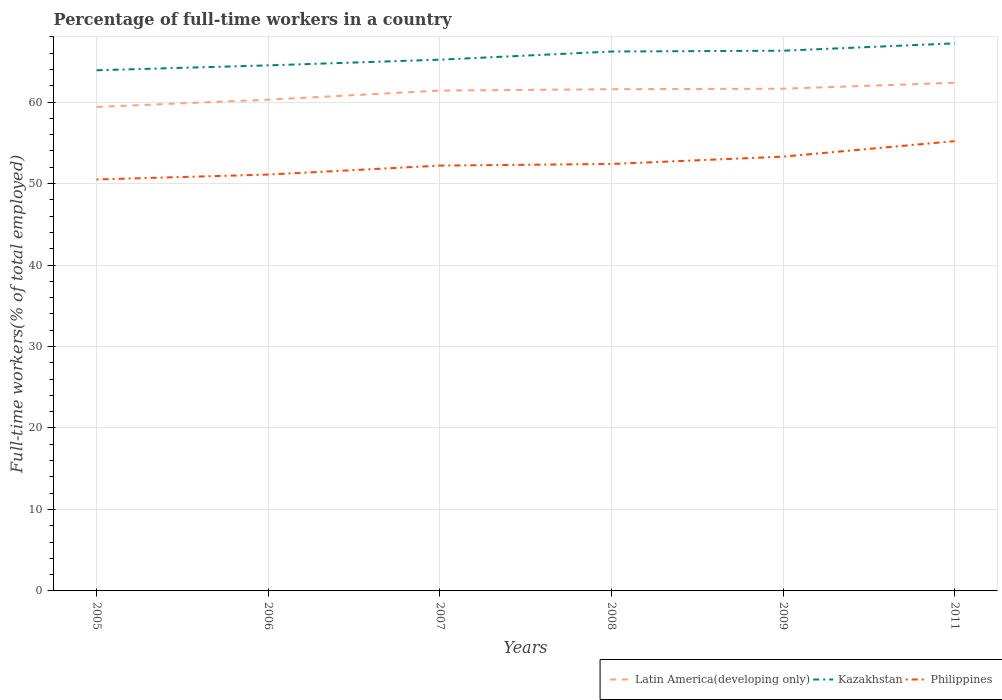Does the line corresponding to Latin America(developing only) intersect with the line corresponding to Philippines?
Ensure brevity in your answer.  No. Across all years, what is the maximum percentage of full-time workers in Philippines?
Give a very brief answer. 50.5. In which year was the percentage of full-time workers in Philippines maximum?
Provide a short and direct response. 2005. What is the difference between the highest and the second highest percentage of full-time workers in Latin America(developing only)?
Provide a succinct answer. 2.97. What is the difference between the highest and the lowest percentage of full-time workers in Philippines?
Make the answer very short. 2. How many lines are there?
Make the answer very short. 3. What is the difference between two consecutive major ticks on the Y-axis?
Ensure brevity in your answer.  10. Does the graph contain grids?
Your answer should be very brief. Yes. Where does the legend appear in the graph?
Offer a terse response. Bottom right. How are the legend labels stacked?
Provide a short and direct response. Horizontal. What is the title of the graph?
Provide a succinct answer. Percentage of full-time workers in a country. Does "Aruba" appear as one of the legend labels in the graph?
Offer a very short reply. No. What is the label or title of the Y-axis?
Your response must be concise. Full-time workers(% of total employed). What is the Full-time workers(% of total employed) in Latin America(developing only) in 2005?
Your answer should be very brief. 59.4. What is the Full-time workers(% of total employed) of Kazakhstan in 2005?
Ensure brevity in your answer.  63.9. What is the Full-time workers(% of total employed) of Philippines in 2005?
Give a very brief answer. 50.5. What is the Full-time workers(% of total employed) in Latin America(developing only) in 2006?
Offer a very short reply. 60.29. What is the Full-time workers(% of total employed) in Kazakhstan in 2006?
Make the answer very short. 64.5. What is the Full-time workers(% of total employed) in Philippines in 2006?
Offer a terse response. 51.1. What is the Full-time workers(% of total employed) in Latin America(developing only) in 2007?
Provide a short and direct response. 61.41. What is the Full-time workers(% of total employed) of Kazakhstan in 2007?
Make the answer very short. 65.2. What is the Full-time workers(% of total employed) of Philippines in 2007?
Your response must be concise. 52.2. What is the Full-time workers(% of total employed) of Latin America(developing only) in 2008?
Your answer should be very brief. 61.57. What is the Full-time workers(% of total employed) of Kazakhstan in 2008?
Your answer should be very brief. 66.2. What is the Full-time workers(% of total employed) in Philippines in 2008?
Offer a terse response. 52.4. What is the Full-time workers(% of total employed) of Latin America(developing only) in 2009?
Keep it short and to the point. 61.64. What is the Full-time workers(% of total employed) of Kazakhstan in 2009?
Offer a terse response. 66.3. What is the Full-time workers(% of total employed) of Philippines in 2009?
Make the answer very short. 53.3. What is the Full-time workers(% of total employed) of Latin America(developing only) in 2011?
Give a very brief answer. 62.37. What is the Full-time workers(% of total employed) in Kazakhstan in 2011?
Provide a short and direct response. 67.2. What is the Full-time workers(% of total employed) in Philippines in 2011?
Give a very brief answer. 55.2. Across all years, what is the maximum Full-time workers(% of total employed) of Latin America(developing only)?
Make the answer very short. 62.37. Across all years, what is the maximum Full-time workers(% of total employed) in Kazakhstan?
Your response must be concise. 67.2. Across all years, what is the maximum Full-time workers(% of total employed) of Philippines?
Your answer should be compact. 55.2. Across all years, what is the minimum Full-time workers(% of total employed) in Latin America(developing only)?
Make the answer very short. 59.4. Across all years, what is the minimum Full-time workers(% of total employed) of Kazakhstan?
Give a very brief answer. 63.9. Across all years, what is the minimum Full-time workers(% of total employed) in Philippines?
Offer a terse response. 50.5. What is the total Full-time workers(% of total employed) in Latin America(developing only) in the graph?
Ensure brevity in your answer.  366.67. What is the total Full-time workers(% of total employed) in Kazakhstan in the graph?
Provide a short and direct response. 393.3. What is the total Full-time workers(% of total employed) in Philippines in the graph?
Provide a succinct answer. 314.7. What is the difference between the Full-time workers(% of total employed) of Latin America(developing only) in 2005 and that in 2006?
Make the answer very short. -0.89. What is the difference between the Full-time workers(% of total employed) in Philippines in 2005 and that in 2006?
Provide a short and direct response. -0.6. What is the difference between the Full-time workers(% of total employed) of Latin America(developing only) in 2005 and that in 2007?
Your response must be concise. -2.01. What is the difference between the Full-time workers(% of total employed) of Latin America(developing only) in 2005 and that in 2008?
Your answer should be very brief. -2.18. What is the difference between the Full-time workers(% of total employed) of Kazakhstan in 2005 and that in 2008?
Your response must be concise. -2.3. What is the difference between the Full-time workers(% of total employed) of Latin America(developing only) in 2005 and that in 2009?
Offer a very short reply. -2.24. What is the difference between the Full-time workers(% of total employed) of Philippines in 2005 and that in 2009?
Keep it short and to the point. -2.8. What is the difference between the Full-time workers(% of total employed) in Latin America(developing only) in 2005 and that in 2011?
Offer a terse response. -2.97. What is the difference between the Full-time workers(% of total employed) in Kazakhstan in 2005 and that in 2011?
Your answer should be very brief. -3.3. What is the difference between the Full-time workers(% of total employed) in Latin America(developing only) in 2006 and that in 2007?
Keep it short and to the point. -1.12. What is the difference between the Full-time workers(% of total employed) of Philippines in 2006 and that in 2007?
Keep it short and to the point. -1.1. What is the difference between the Full-time workers(% of total employed) in Latin America(developing only) in 2006 and that in 2008?
Your answer should be very brief. -1.28. What is the difference between the Full-time workers(% of total employed) in Philippines in 2006 and that in 2008?
Provide a succinct answer. -1.3. What is the difference between the Full-time workers(% of total employed) in Latin America(developing only) in 2006 and that in 2009?
Ensure brevity in your answer.  -1.35. What is the difference between the Full-time workers(% of total employed) in Kazakhstan in 2006 and that in 2009?
Your answer should be very brief. -1.8. What is the difference between the Full-time workers(% of total employed) in Philippines in 2006 and that in 2009?
Your answer should be very brief. -2.2. What is the difference between the Full-time workers(% of total employed) of Latin America(developing only) in 2006 and that in 2011?
Provide a succinct answer. -2.08. What is the difference between the Full-time workers(% of total employed) of Philippines in 2006 and that in 2011?
Provide a succinct answer. -4.1. What is the difference between the Full-time workers(% of total employed) in Latin America(developing only) in 2007 and that in 2008?
Keep it short and to the point. -0.17. What is the difference between the Full-time workers(% of total employed) of Kazakhstan in 2007 and that in 2008?
Offer a very short reply. -1. What is the difference between the Full-time workers(% of total employed) in Philippines in 2007 and that in 2008?
Make the answer very short. -0.2. What is the difference between the Full-time workers(% of total employed) of Latin America(developing only) in 2007 and that in 2009?
Make the answer very short. -0.23. What is the difference between the Full-time workers(% of total employed) of Kazakhstan in 2007 and that in 2009?
Keep it short and to the point. -1.1. What is the difference between the Full-time workers(% of total employed) in Philippines in 2007 and that in 2009?
Provide a succinct answer. -1.1. What is the difference between the Full-time workers(% of total employed) of Latin America(developing only) in 2007 and that in 2011?
Your response must be concise. -0.96. What is the difference between the Full-time workers(% of total employed) of Kazakhstan in 2007 and that in 2011?
Ensure brevity in your answer.  -2. What is the difference between the Full-time workers(% of total employed) in Latin America(developing only) in 2008 and that in 2009?
Give a very brief answer. -0.06. What is the difference between the Full-time workers(% of total employed) in Kazakhstan in 2008 and that in 2009?
Give a very brief answer. -0.1. What is the difference between the Full-time workers(% of total employed) in Philippines in 2008 and that in 2009?
Make the answer very short. -0.9. What is the difference between the Full-time workers(% of total employed) in Latin America(developing only) in 2008 and that in 2011?
Ensure brevity in your answer.  -0.79. What is the difference between the Full-time workers(% of total employed) in Latin America(developing only) in 2009 and that in 2011?
Your response must be concise. -0.73. What is the difference between the Full-time workers(% of total employed) in Kazakhstan in 2009 and that in 2011?
Your answer should be compact. -0.9. What is the difference between the Full-time workers(% of total employed) of Philippines in 2009 and that in 2011?
Give a very brief answer. -1.9. What is the difference between the Full-time workers(% of total employed) of Latin America(developing only) in 2005 and the Full-time workers(% of total employed) of Kazakhstan in 2006?
Your response must be concise. -5.1. What is the difference between the Full-time workers(% of total employed) of Latin America(developing only) in 2005 and the Full-time workers(% of total employed) of Philippines in 2006?
Your response must be concise. 8.3. What is the difference between the Full-time workers(% of total employed) of Kazakhstan in 2005 and the Full-time workers(% of total employed) of Philippines in 2006?
Your response must be concise. 12.8. What is the difference between the Full-time workers(% of total employed) of Latin America(developing only) in 2005 and the Full-time workers(% of total employed) of Kazakhstan in 2007?
Provide a short and direct response. -5.8. What is the difference between the Full-time workers(% of total employed) in Latin America(developing only) in 2005 and the Full-time workers(% of total employed) in Philippines in 2007?
Keep it short and to the point. 7.2. What is the difference between the Full-time workers(% of total employed) in Kazakhstan in 2005 and the Full-time workers(% of total employed) in Philippines in 2007?
Ensure brevity in your answer.  11.7. What is the difference between the Full-time workers(% of total employed) of Latin America(developing only) in 2005 and the Full-time workers(% of total employed) of Kazakhstan in 2008?
Give a very brief answer. -6.8. What is the difference between the Full-time workers(% of total employed) of Latin America(developing only) in 2005 and the Full-time workers(% of total employed) of Philippines in 2008?
Your answer should be very brief. 7. What is the difference between the Full-time workers(% of total employed) in Latin America(developing only) in 2005 and the Full-time workers(% of total employed) in Kazakhstan in 2009?
Offer a very short reply. -6.9. What is the difference between the Full-time workers(% of total employed) in Latin America(developing only) in 2005 and the Full-time workers(% of total employed) in Philippines in 2009?
Give a very brief answer. 6.1. What is the difference between the Full-time workers(% of total employed) of Latin America(developing only) in 2005 and the Full-time workers(% of total employed) of Kazakhstan in 2011?
Your answer should be compact. -7.8. What is the difference between the Full-time workers(% of total employed) of Latin America(developing only) in 2005 and the Full-time workers(% of total employed) of Philippines in 2011?
Your answer should be compact. 4.2. What is the difference between the Full-time workers(% of total employed) in Kazakhstan in 2005 and the Full-time workers(% of total employed) in Philippines in 2011?
Keep it short and to the point. 8.7. What is the difference between the Full-time workers(% of total employed) in Latin America(developing only) in 2006 and the Full-time workers(% of total employed) in Kazakhstan in 2007?
Provide a short and direct response. -4.91. What is the difference between the Full-time workers(% of total employed) of Latin America(developing only) in 2006 and the Full-time workers(% of total employed) of Philippines in 2007?
Make the answer very short. 8.09. What is the difference between the Full-time workers(% of total employed) in Kazakhstan in 2006 and the Full-time workers(% of total employed) in Philippines in 2007?
Offer a very short reply. 12.3. What is the difference between the Full-time workers(% of total employed) in Latin America(developing only) in 2006 and the Full-time workers(% of total employed) in Kazakhstan in 2008?
Your response must be concise. -5.91. What is the difference between the Full-time workers(% of total employed) of Latin America(developing only) in 2006 and the Full-time workers(% of total employed) of Philippines in 2008?
Keep it short and to the point. 7.89. What is the difference between the Full-time workers(% of total employed) of Kazakhstan in 2006 and the Full-time workers(% of total employed) of Philippines in 2008?
Offer a terse response. 12.1. What is the difference between the Full-time workers(% of total employed) in Latin America(developing only) in 2006 and the Full-time workers(% of total employed) in Kazakhstan in 2009?
Your answer should be very brief. -6.01. What is the difference between the Full-time workers(% of total employed) in Latin America(developing only) in 2006 and the Full-time workers(% of total employed) in Philippines in 2009?
Provide a short and direct response. 6.99. What is the difference between the Full-time workers(% of total employed) of Kazakhstan in 2006 and the Full-time workers(% of total employed) of Philippines in 2009?
Offer a terse response. 11.2. What is the difference between the Full-time workers(% of total employed) in Latin America(developing only) in 2006 and the Full-time workers(% of total employed) in Kazakhstan in 2011?
Provide a succinct answer. -6.91. What is the difference between the Full-time workers(% of total employed) of Latin America(developing only) in 2006 and the Full-time workers(% of total employed) of Philippines in 2011?
Keep it short and to the point. 5.09. What is the difference between the Full-time workers(% of total employed) of Kazakhstan in 2006 and the Full-time workers(% of total employed) of Philippines in 2011?
Keep it short and to the point. 9.3. What is the difference between the Full-time workers(% of total employed) of Latin America(developing only) in 2007 and the Full-time workers(% of total employed) of Kazakhstan in 2008?
Offer a terse response. -4.79. What is the difference between the Full-time workers(% of total employed) of Latin America(developing only) in 2007 and the Full-time workers(% of total employed) of Philippines in 2008?
Your response must be concise. 9.01. What is the difference between the Full-time workers(% of total employed) in Kazakhstan in 2007 and the Full-time workers(% of total employed) in Philippines in 2008?
Keep it short and to the point. 12.8. What is the difference between the Full-time workers(% of total employed) in Latin America(developing only) in 2007 and the Full-time workers(% of total employed) in Kazakhstan in 2009?
Provide a succinct answer. -4.89. What is the difference between the Full-time workers(% of total employed) of Latin America(developing only) in 2007 and the Full-time workers(% of total employed) of Philippines in 2009?
Ensure brevity in your answer.  8.11. What is the difference between the Full-time workers(% of total employed) in Latin America(developing only) in 2007 and the Full-time workers(% of total employed) in Kazakhstan in 2011?
Your response must be concise. -5.79. What is the difference between the Full-time workers(% of total employed) of Latin America(developing only) in 2007 and the Full-time workers(% of total employed) of Philippines in 2011?
Keep it short and to the point. 6.21. What is the difference between the Full-time workers(% of total employed) in Kazakhstan in 2007 and the Full-time workers(% of total employed) in Philippines in 2011?
Your response must be concise. 10. What is the difference between the Full-time workers(% of total employed) in Latin America(developing only) in 2008 and the Full-time workers(% of total employed) in Kazakhstan in 2009?
Give a very brief answer. -4.73. What is the difference between the Full-time workers(% of total employed) in Latin America(developing only) in 2008 and the Full-time workers(% of total employed) in Philippines in 2009?
Give a very brief answer. 8.27. What is the difference between the Full-time workers(% of total employed) in Kazakhstan in 2008 and the Full-time workers(% of total employed) in Philippines in 2009?
Give a very brief answer. 12.9. What is the difference between the Full-time workers(% of total employed) in Latin America(developing only) in 2008 and the Full-time workers(% of total employed) in Kazakhstan in 2011?
Make the answer very short. -5.63. What is the difference between the Full-time workers(% of total employed) in Latin America(developing only) in 2008 and the Full-time workers(% of total employed) in Philippines in 2011?
Provide a short and direct response. 6.37. What is the difference between the Full-time workers(% of total employed) in Latin America(developing only) in 2009 and the Full-time workers(% of total employed) in Kazakhstan in 2011?
Provide a short and direct response. -5.56. What is the difference between the Full-time workers(% of total employed) in Latin America(developing only) in 2009 and the Full-time workers(% of total employed) in Philippines in 2011?
Offer a very short reply. 6.44. What is the difference between the Full-time workers(% of total employed) in Kazakhstan in 2009 and the Full-time workers(% of total employed) in Philippines in 2011?
Provide a succinct answer. 11.1. What is the average Full-time workers(% of total employed) of Latin America(developing only) per year?
Your answer should be very brief. 61.11. What is the average Full-time workers(% of total employed) of Kazakhstan per year?
Provide a succinct answer. 65.55. What is the average Full-time workers(% of total employed) in Philippines per year?
Your answer should be very brief. 52.45. In the year 2005, what is the difference between the Full-time workers(% of total employed) in Latin America(developing only) and Full-time workers(% of total employed) in Kazakhstan?
Your answer should be compact. -4.5. In the year 2005, what is the difference between the Full-time workers(% of total employed) in Latin America(developing only) and Full-time workers(% of total employed) in Philippines?
Keep it short and to the point. 8.9. In the year 2006, what is the difference between the Full-time workers(% of total employed) of Latin America(developing only) and Full-time workers(% of total employed) of Kazakhstan?
Your answer should be compact. -4.21. In the year 2006, what is the difference between the Full-time workers(% of total employed) of Latin America(developing only) and Full-time workers(% of total employed) of Philippines?
Make the answer very short. 9.19. In the year 2007, what is the difference between the Full-time workers(% of total employed) of Latin America(developing only) and Full-time workers(% of total employed) of Kazakhstan?
Provide a succinct answer. -3.79. In the year 2007, what is the difference between the Full-time workers(% of total employed) of Latin America(developing only) and Full-time workers(% of total employed) of Philippines?
Your response must be concise. 9.21. In the year 2008, what is the difference between the Full-time workers(% of total employed) in Latin America(developing only) and Full-time workers(% of total employed) in Kazakhstan?
Give a very brief answer. -4.63. In the year 2008, what is the difference between the Full-time workers(% of total employed) in Latin America(developing only) and Full-time workers(% of total employed) in Philippines?
Keep it short and to the point. 9.17. In the year 2008, what is the difference between the Full-time workers(% of total employed) of Kazakhstan and Full-time workers(% of total employed) of Philippines?
Keep it short and to the point. 13.8. In the year 2009, what is the difference between the Full-time workers(% of total employed) of Latin America(developing only) and Full-time workers(% of total employed) of Kazakhstan?
Offer a very short reply. -4.66. In the year 2009, what is the difference between the Full-time workers(% of total employed) in Latin America(developing only) and Full-time workers(% of total employed) in Philippines?
Offer a terse response. 8.34. In the year 2009, what is the difference between the Full-time workers(% of total employed) in Kazakhstan and Full-time workers(% of total employed) in Philippines?
Keep it short and to the point. 13. In the year 2011, what is the difference between the Full-time workers(% of total employed) of Latin America(developing only) and Full-time workers(% of total employed) of Kazakhstan?
Keep it short and to the point. -4.83. In the year 2011, what is the difference between the Full-time workers(% of total employed) of Latin America(developing only) and Full-time workers(% of total employed) of Philippines?
Your answer should be compact. 7.17. What is the ratio of the Full-time workers(% of total employed) of Latin America(developing only) in 2005 to that in 2006?
Offer a very short reply. 0.99. What is the ratio of the Full-time workers(% of total employed) of Philippines in 2005 to that in 2006?
Offer a very short reply. 0.99. What is the ratio of the Full-time workers(% of total employed) of Latin America(developing only) in 2005 to that in 2007?
Offer a terse response. 0.97. What is the ratio of the Full-time workers(% of total employed) of Kazakhstan in 2005 to that in 2007?
Ensure brevity in your answer.  0.98. What is the ratio of the Full-time workers(% of total employed) of Philippines in 2005 to that in 2007?
Offer a very short reply. 0.97. What is the ratio of the Full-time workers(% of total employed) in Latin America(developing only) in 2005 to that in 2008?
Your answer should be compact. 0.96. What is the ratio of the Full-time workers(% of total employed) in Kazakhstan in 2005 to that in 2008?
Provide a short and direct response. 0.97. What is the ratio of the Full-time workers(% of total employed) in Philippines in 2005 to that in 2008?
Your response must be concise. 0.96. What is the ratio of the Full-time workers(% of total employed) in Latin America(developing only) in 2005 to that in 2009?
Your answer should be compact. 0.96. What is the ratio of the Full-time workers(% of total employed) in Kazakhstan in 2005 to that in 2009?
Your answer should be compact. 0.96. What is the ratio of the Full-time workers(% of total employed) in Philippines in 2005 to that in 2009?
Give a very brief answer. 0.95. What is the ratio of the Full-time workers(% of total employed) in Kazakhstan in 2005 to that in 2011?
Make the answer very short. 0.95. What is the ratio of the Full-time workers(% of total employed) in Philippines in 2005 to that in 2011?
Your response must be concise. 0.91. What is the ratio of the Full-time workers(% of total employed) of Latin America(developing only) in 2006 to that in 2007?
Offer a terse response. 0.98. What is the ratio of the Full-time workers(% of total employed) in Kazakhstan in 2006 to that in 2007?
Your answer should be compact. 0.99. What is the ratio of the Full-time workers(% of total employed) of Philippines in 2006 to that in 2007?
Give a very brief answer. 0.98. What is the ratio of the Full-time workers(% of total employed) of Latin America(developing only) in 2006 to that in 2008?
Your answer should be very brief. 0.98. What is the ratio of the Full-time workers(% of total employed) in Kazakhstan in 2006 to that in 2008?
Make the answer very short. 0.97. What is the ratio of the Full-time workers(% of total employed) of Philippines in 2006 to that in 2008?
Keep it short and to the point. 0.98. What is the ratio of the Full-time workers(% of total employed) of Latin America(developing only) in 2006 to that in 2009?
Your answer should be compact. 0.98. What is the ratio of the Full-time workers(% of total employed) of Kazakhstan in 2006 to that in 2009?
Your answer should be very brief. 0.97. What is the ratio of the Full-time workers(% of total employed) in Philippines in 2006 to that in 2009?
Keep it short and to the point. 0.96. What is the ratio of the Full-time workers(% of total employed) in Latin America(developing only) in 2006 to that in 2011?
Provide a short and direct response. 0.97. What is the ratio of the Full-time workers(% of total employed) in Kazakhstan in 2006 to that in 2011?
Ensure brevity in your answer.  0.96. What is the ratio of the Full-time workers(% of total employed) in Philippines in 2006 to that in 2011?
Your answer should be compact. 0.93. What is the ratio of the Full-time workers(% of total employed) of Latin America(developing only) in 2007 to that in 2008?
Offer a terse response. 1. What is the ratio of the Full-time workers(% of total employed) in Kazakhstan in 2007 to that in 2008?
Give a very brief answer. 0.98. What is the ratio of the Full-time workers(% of total employed) of Philippines in 2007 to that in 2008?
Give a very brief answer. 1. What is the ratio of the Full-time workers(% of total employed) in Kazakhstan in 2007 to that in 2009?
Offer a very short reply. 0.98. What is the ratio of the Full-time workers(% of total employed) of Philippines in 2007 to that in 2009?
Your answer should be very brief. 0.98. What is the ratio of the Full-time workers(% of total employed) in Latin America(developing only) in 2007 to that in 2011?
Provide a short and direct response. 0.98. What is the ratio of the Full-time workers(% of total employed) of Kazakhstan in 2007 to that in 2011?
Provide a succinct answer. 0.97. What is the ratio of the Full-time workers(% of total employed) of Philippines in 2007 to that in 2011?
Your answer should be compact. 0.95. What is the ratio of the Full-time workers(% of total employed) in Latin America(developing only) in 2008 to that in 2009?
Provide a succinct answer. 1. What is the ratio of the Full-time workers(% of total employed) in Kazakhstan in 2008 to that in 2009?
Your answer should be very brief. 1. What is the ratio of the Full-time workers(% of total employed) in Philippines in 2008 to that in 2009?
Your response must be concise. 0.98. What is the ratio of the Full-time workers(% of total employed) in Latin America(developing only) in 2008 to that in 2011?
Your answer should be very brief. 0.99. What is the ratio of the Full-time workers(% of total employed) of Kazakhstan in 2008 to that in 2011?
Give a very brief answer. 0.99. What is the ratio of the Full-time workers(% of total employed) in Philippines in 2008 to that in 2011?
Make the answer very short. 0.95. What is the ratio of the Full-time workers(% of total employed) of Latin America(developing only) in 2009 to that in 2011?
Make the answer very short. 0.99. What is the ratio of the Full-time workers(% of total employed) in Kazakhstan in 2009 to that in 2011?
Your response must be concise. 0.99. What is the ratio of the Full-time workers(% of total employed) in Philippines in 2009 to that in 2011?
Give a very brief answer. 0.97. What is the difference between the highest and the second highest Full-time workers(% of total employed) of Latin America(developing only)?
Your response must be concise. 0.73. What is the difference between the highest and the second highest Full-time workers(% of total employed) in Philippines?
Give a very brief answer. 1.9. What is the difference between the highest and the lowest Full-time workers(% of total employed) in Latin America(developing only)?
Offer a terse response. 2.97. What is the difference between the highest and the lowest Full-time workers(% of total employed) in Kazakhstan?
Keep it short and to the point. 3.3. 